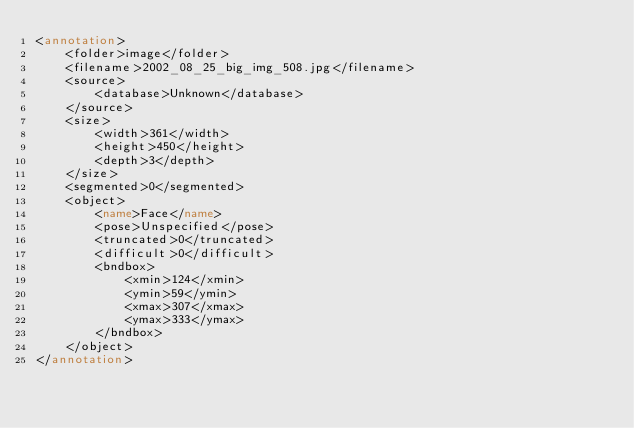<code> <loc_0><loc_0><loc_500><loc_500><_XML_><annotation>
    <folder>image</folder>
    <filename>2002_08_25_big_img_508.jpg</filename>
    <source>
        <database>Unknown</database>
    </source>
    <size>
        <width>361</width>
        <height>450</height>
        <depth>3</depth>
    </size>
    <segmented>0</segmented>
    <object>
        <name>Face</name>
        <pose>Unspecified</pose>
        <truncated>0</truncated>
        <difficult>0</difficult>
        <bndbox>
            <xmin>124</xmin>
            <ymin>59</ymin>
            <xmax>307</xmax>
            <ymax>333</ymax>
        </bndbox>
    </object>
</annotation></code> 